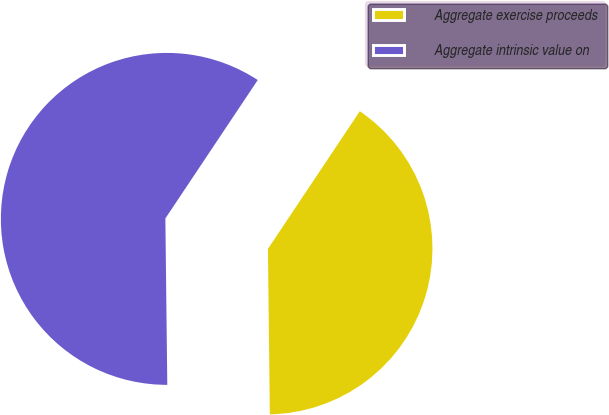Convert chart. <chart><loc_0><loc_0><loc_500><loc_500><pie_chart><fcel>Aggregate exercise proceeds<fcel>Aggregate intrinsic value on<nl><fcel>40.45%<fcel>59.55%<nl></chart> 